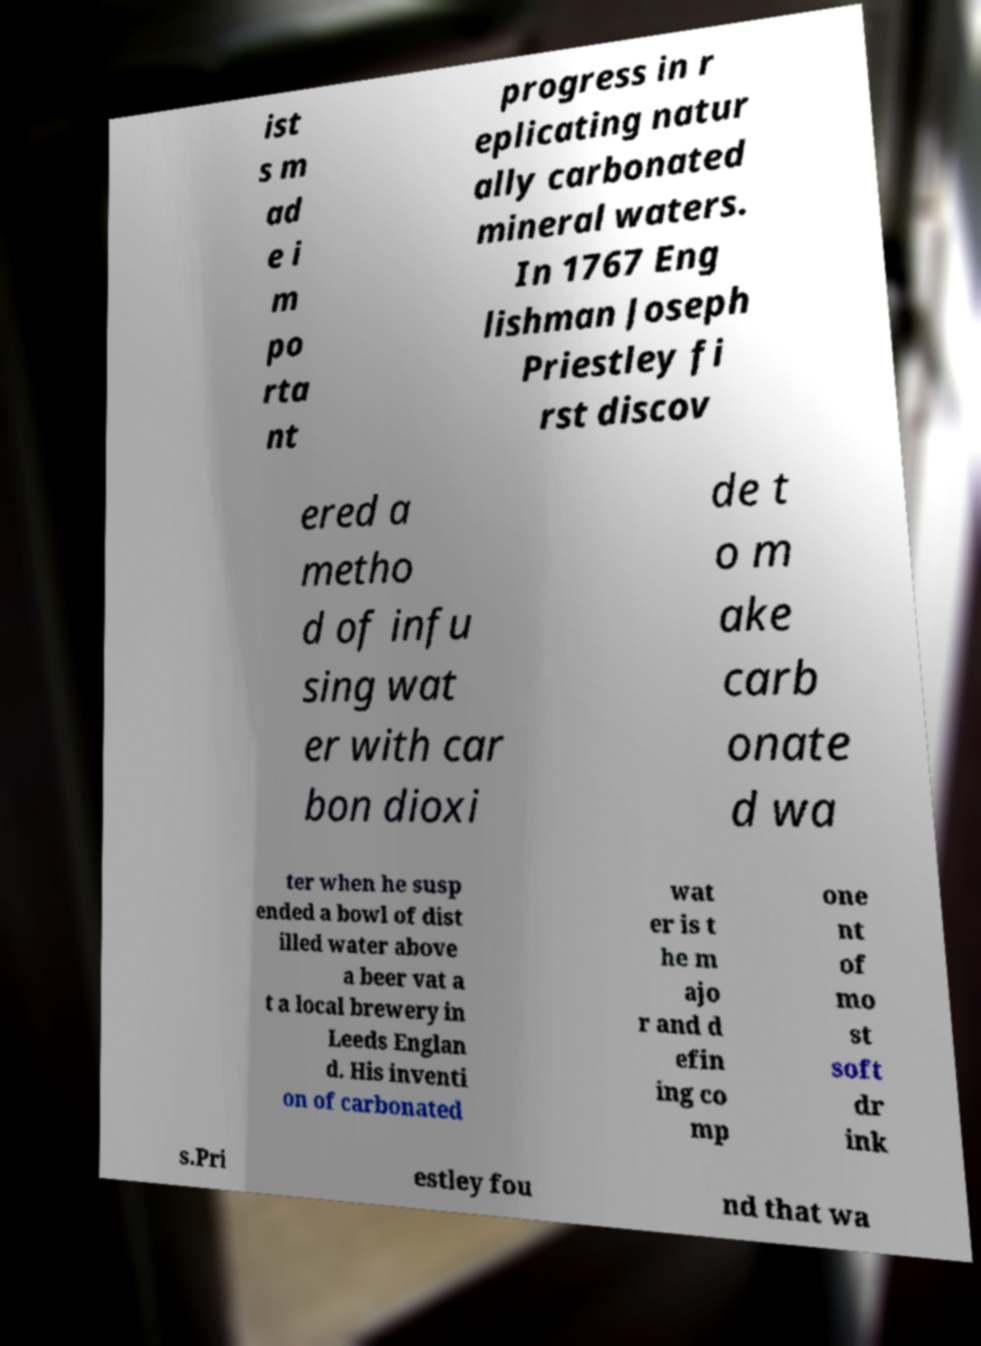Can you accurately transcribe the text from the provided image for me? ist s m ad e i m po rta nt progress in r eplicating natur ally carbonated mineral waters. In 1767 Eng lishman Joseph Priestley fi rst discov ered a metho d of infu sing wat er with car bon dioxi de t o m ake carb onate d wa ter when he susp ended a bowl of dist illed water above a beer vat a t a local brewery in Leeds Englan d. His inventi on of carbonated wat er is t he m ajo r and d efin ing co mp one nt of mo st soft dr ink s.Pri estley fou nd that wa 